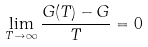Convert formula to latex. <formula><loc_0><loc_0><loc_500><loc_500>\lim _ { T \to \infty } \frac { G ( T ) - G } { T } = 0</formula> 